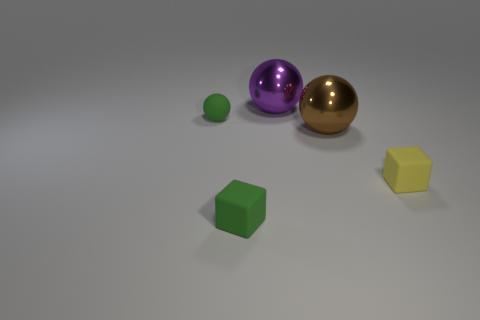There is a tiny object that is the same color as the tiny ball; what is its material?
Make the answer very short. Rubber. Is there anything else that is the same shape as the purple metallic object?
Make the answer very short. Yes. There is a thing that is both in front of the brown object and right of the purple object; what material is it?
Offer a terse response. Rubber. Are the brown thing and the small cube in front of the small yellow object made of the same material?
Your answer should be compact. No. Is there anything else that has the same size as the matte sphere?
Make the answer very short. Yes. What number of objects are tiny rubber blocks or large metal balls in front of the purple sphere?
Your response must be concise. 3. There is a green rubber object that is behind the yellow rubber block; is it the same size as the rubber object that is to the right of the large purple sphere?
Give a very brief answer. Yes. How many other things are the same color as the matte sphere?
Keep it short and to the point. 1. Does the brown metallic ball have the same size as the metal ball behind the rubber sphere?
Offer a very short reply. Yes. How big is the rubber block to the right of the metal ball in front of the purple shiny ball?
Provide a short and direct response. Small. 